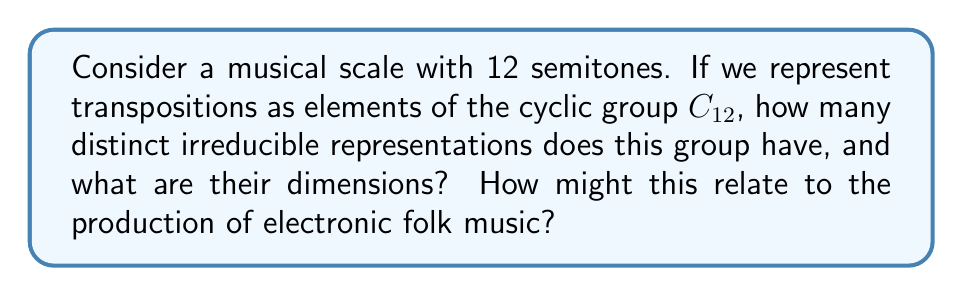Show me your answer to this math problem. Let's approach this step-by-step:

1) The cyclic group $C_{12}$ represents the 12 possible transpositions of a musical scale.

2) For any cyclic group $C_n$, the number of irreducible representations is equal to the number of divisors of $n$.

3) The divisors of 12 are 1, 2, 3, 4, 6, and 12.

4) Therefore, $C_{12}$ has 6 irreducible representations.

5) For a cyclic group, all irreducible representations are one-dimensional.

6) The irreducible representations of $C_{12}$ can be described as:

   $$\rho_k: C_{12} \to \mathbb{C}^*, \quad \rho_k(g) = e^{2\pi i k/12}$$

   where $k = 0, 1, 2, ..., 11$.

7) In the context of electronic folk music production:
   - Each representation corresponds to a different "harmonic color" or tonal center.
   - The one-dimensional nature of these representations aligns with the idea of transposing a entire folk melody or chord progression.
   - Electronic production techniques could utilize these mathematical relationships to create interesting harmonic shifts or modulations in folk-inspired compositions.
Answer: 6 irreducible representations, all 1-dimensional. 